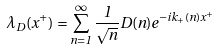Convert formula to latex. <formula><loc_0><loc_0><loc_500><loc_500>\lambda _ { D } ( x ^ { + } ) = \sum _ { n = 1 } ^ { \infty } \frac { 1 } { \sqrt { n } } D ( n ) e ^ { - i k _ { + } ( n ) x ^ { + } }</formula> 